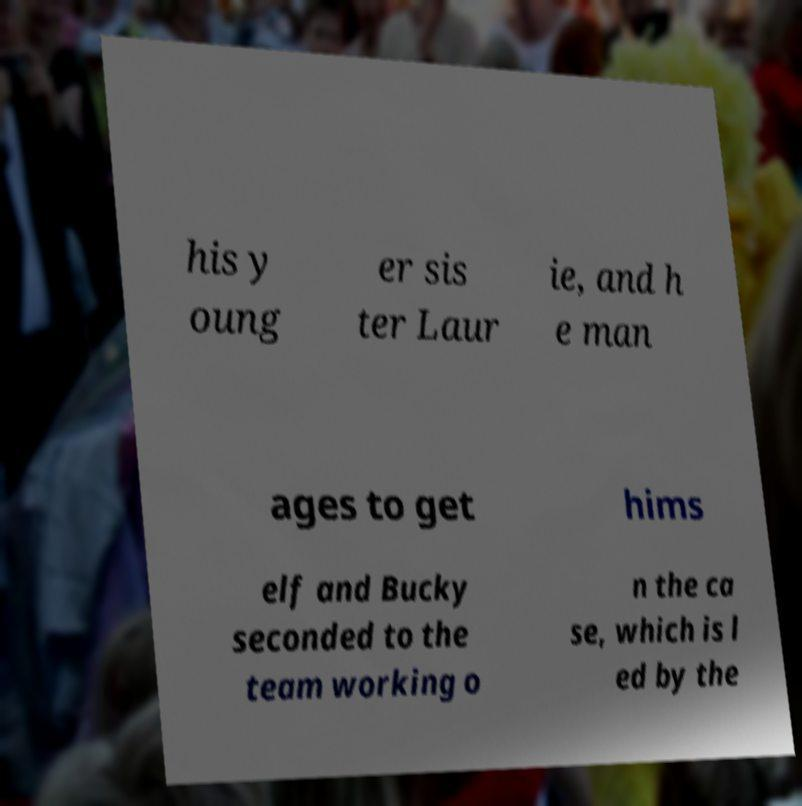For documentation purposes, I need the text within this image transcribed. Could you provide that? his y oung er sis ter Laur ie, and h e man ages to get hims elf and Bucky seconded to the team working o n the ca se, which is l ed by the 